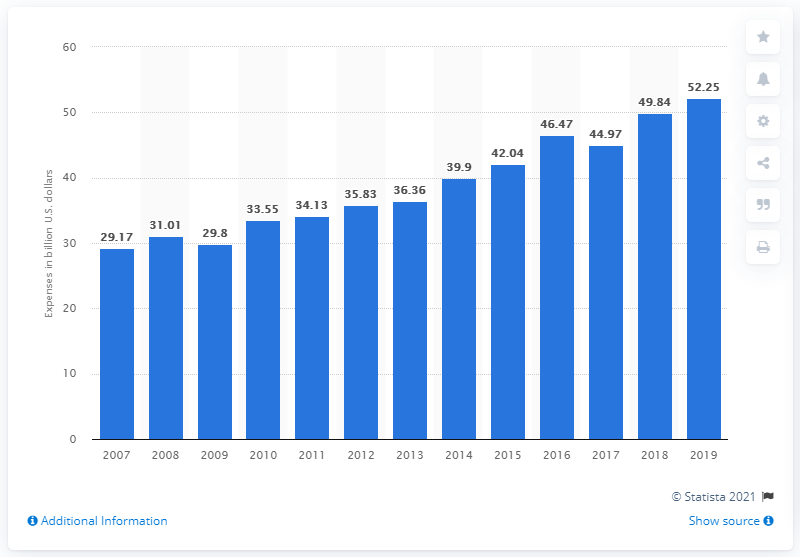Indicate a few pertinent items in this graphic. In 2018, TV broadcasting companies spent approximately 49.84 on their operations. In 2019, the annual aggregate expenses of television broadcasters in the United States was approximately $52.25 billion. 